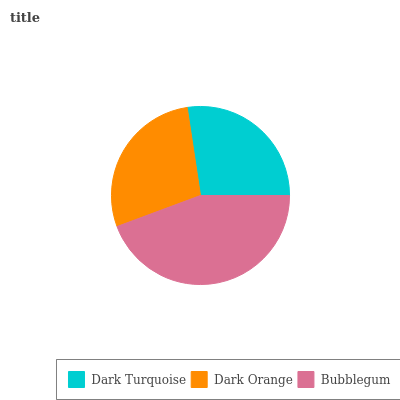Is Dark Turquoise the minimum?
Answer yes or no. Yes. Is Bubblegum the maximum?
Answer yes or no. Yes. Is Dark Orange the minimum?
Answer yes or no. No. Is Dark Orange the maximum?
Answer yes or no. No. Is Dark Orange greater than Dark Turquoise?
Answer yes or no. Yes. Is Dark Turquoise less than Dark Orange?
Answer yes or no. Yes. Is Dark Turquoise greater than Dark Orange?
Answer yes or no. No. Is Dark Orange less than Dark Turquoise?
Answer yes or no. No. Is Dark Orange the high median?
Answer yes or no. Yes. Is Dark Orange the low median?
Answer yes or no. Yes. Is Bubblegum the high median?
Answer yes or no. No. Is Dark Turquoise the low median?
Answer yes or no. No. 